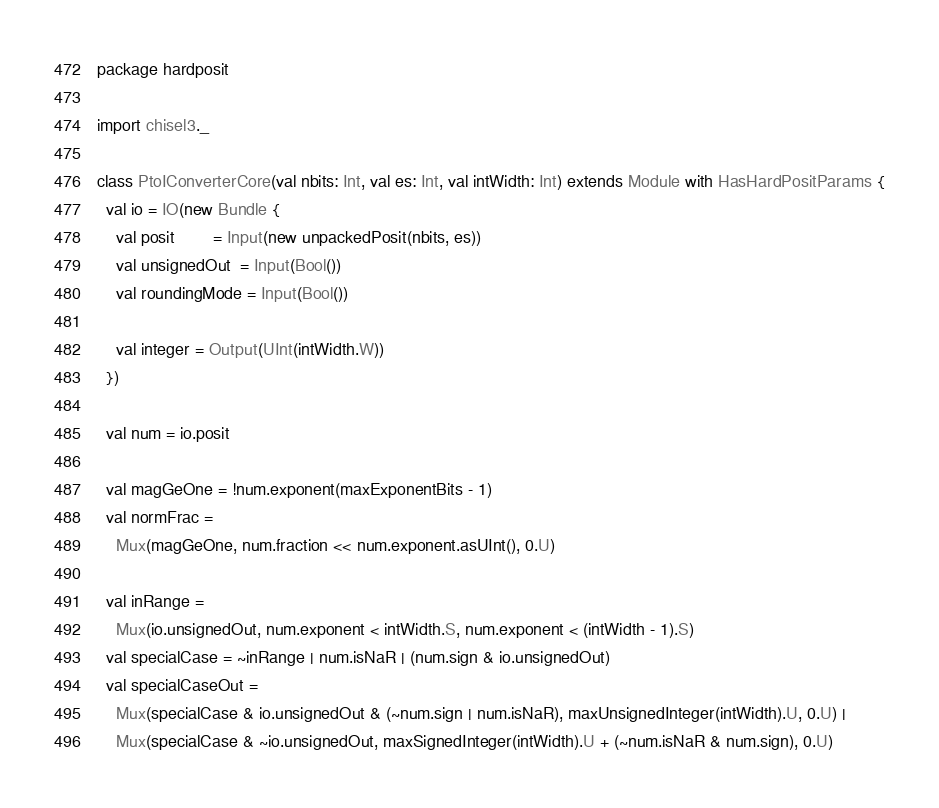Convert code to text. <code><loc_0><loc_0><loc_500><loc_500><_Scala_>package hardposit

import chisel3._

class PtoIConverterCore(val nbits: Int, val es: Int, val intWidth: Int) extends Module with HasHardPositParams {
  val io = IO(new Bundle {
    val posit        = Input(new unpackedPosit(nbits, es))
    val unsignedOut  = Input(Bool())
    val roundingMode = Input(Bool())

    val integer = Output(UInt(intWidth.W))
  })

  val num = io.posit

  val magGeOne = !num.exponent(maxExponentBits - 1)
  val normFrac =
    Mux(magGeOne, num.fraction << num.exponent.asUInt(), 0.U)

  val inRange =
    Mux(io.unsignedOut, num.exponent < intWidth.S, num.exponent < (intWidth - 1).S)
  val specialCase = ~inRange | num.isNaR | (num.sign & io.unsignedOut)
  val specialCaseOut =
    Mux(specialCase & io.unsignedOut & (~num.sign | num.isNaR), maxUnsignedInteger(intWidth).U, 0.U) |
    Mux(specialCase & ~io.unsignedOut, maxSignedInteger(intWidth).U + (~num.isNaR & num.sign), 0.U)
</code> 